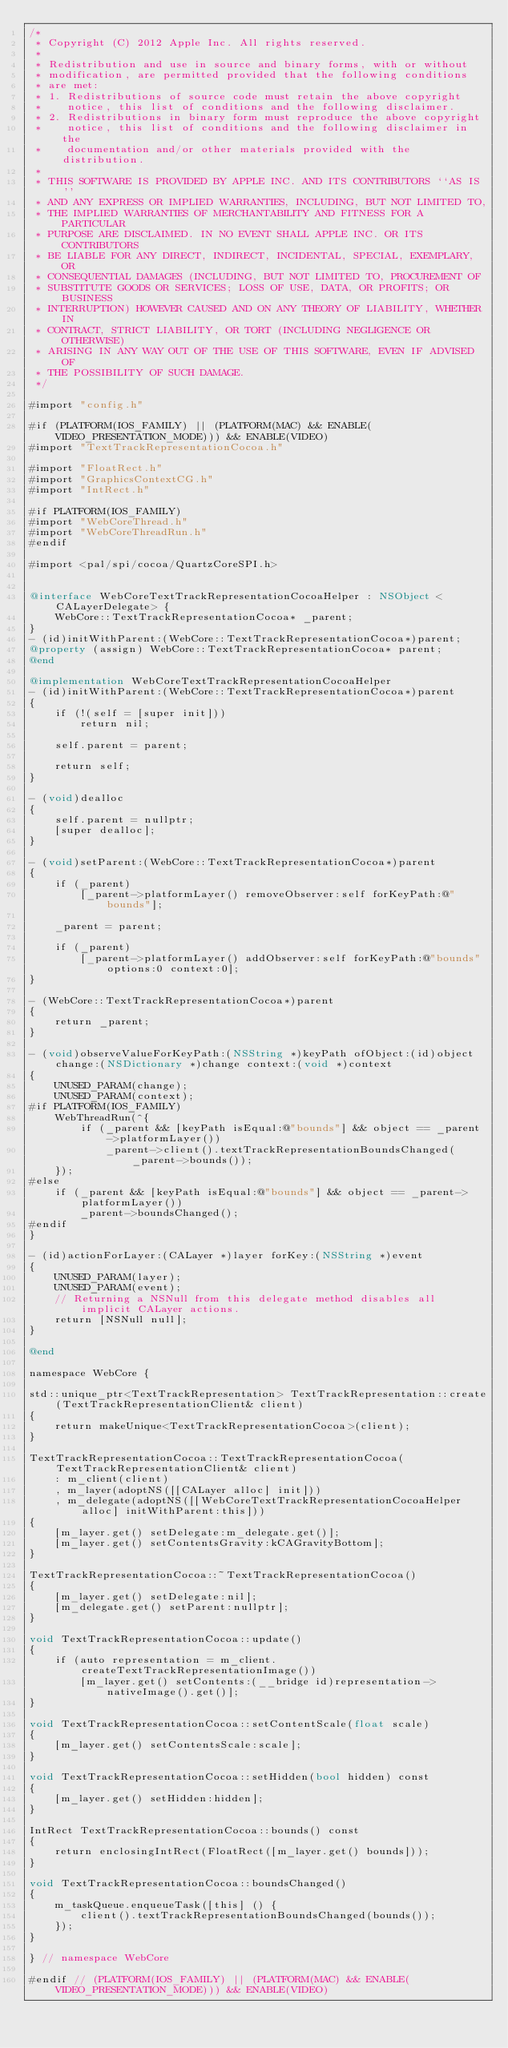Convert code to text. <code><loc_0><loc_0><loc_500><loc_500><_ObjectiveC_>/*
 * Copyright (C) 2012 Apple Inc. All rights reserved.
 *
 * Redistribution and use in source and binary forms, with or without
 * modification, are permitted provided that the following conditions
 * are met:
 * 1. Redistributions of source code must retain the above copyright
 *    notice, this list of conditions and the following disclaimer.
 * 2. Redistributions in binary form must reproduce the above copyright
 *    notice, this list of conditions and the following disclaimer in the
 *    documentation and/or other materials provided with the distribution.
 *
 * THIS SOFTWARE IS PROVIDED BY APPLE INC. AND ITS CONTRIBUTORS ``AS IS''
 * AND ANY EXPRESS OR IMPLIED WARRANTIES, INCLUDING, BUT NOT LIMITED TO,
 * THE IMPLIED WARRANTIES OF MERCHANTABILITY AND FITNESS FOR A PARTICULAR
 * PURPOSE ARE DISCLAIMED. IN NO EVENT SHALL APPLE INC. OR ITS CONTRIBUTORS
 * BE LIABLE FOR ANY DIRECT, INDIRECT, INCIDENTAL, SPECIAL, EXEMPLARY, OR
 * CONSEQUENTIAL DAMAGES (INCLUDING, BUT NOT LIMITED TO, PROCUREMENT OF
 * SUBSTITUTE GOODS OR SERVICES; LOSS OF USE, DATA, OR PROFITS; OR BUSINESS
 * INTERRUPTION) HOWEVER CAUSED AND ON ANY THEORY OF LIABILITY, WHETHER IN
 * CONTRACT, STRICT LIABILITY, OR TORT (INCLUDING NEGLIGENCE OR OTHERWISE)
 * ARISING IN ANY WAY OUT OF THE USE OF THIS SOFTWARE, EVEN IF ADVISED OF
 * THE POSSIBILITY OF SUCH DAMAGE.
 */

#import "config.h"

#if (PLATFORM(IOS_FAMILY) || (PLATFORM(MAC) && ENABLE(VIDEO_PRESENTATION_MODE))) && ENABLE(VIDEO)
#import "TextTrackRepresentationCocoa.h"

#import "FloatRect.h"
#import "GraphicsContextCG.h"
#import "IntRect.h"

#if PLATFORM(IOS_FAMILY)
#import "WebCoreThread.h"
#import "WebCoreThreadRun.h"
#endif

#import <pal/spi/cocoa/QuartzCoreSPI.h>


@interface WebCoreTextTrackRepresentationCocoaHelper : NSObject <CALayerDelegate> {
    WebCore::TextTrackRepresentationCocoa* _parent;
}
- (id)initWithParent:(WebCore::TextTrackRepresentationCocoa*)parent;
@property (assign) WebCore::TextTrackRepresentationCocoa* parent;
@end

@implementation WebCoreTextTrackRepresentationCocoaHelper
- (id)initWithParent:(WebCore::TextTrackRepresentationCocoa*)parent
{
    if (!(self = [super init]))
        return nil;

    self.parent = parent;

    return self;
}

- (void)dealloc
{
    self.parent = nullptr;
    [super dealloc];
}

- (void)setParent:(WebCore::TextTrackRepresentationCocoa*)parent
{
    if (_parent)
        [_parent->platformLayer() removeObserver:self forKeyPath:@"bounds"];

    _parent = parent;

    if (_parent)
        [_parent->platformLayer() addObserver:self forKeyPath:@"bounds" options:0 context:0];
}

- (WebCore::TextTrackRepresentationCocoa*)parent
{
    return _parent;
}

- (void)observeValueForKeyPath:(NSString *)keyPath ofObject:(id)object change:(NSDictionary *)change context:(void *)context
{
    UNUSED_PARAM(change);
    UNUSED_PARAM(context);
#if PLATFORM(IOS_FAMILY)
    WebThreadRun(^{
        if (_parent && [keyPath isEqual:@"bounds"] && object == _parent->platformLayer())
            _parent->client().textTrackRepresentationBoundsChanged(_parent->bounds());
    });
#else
    if (_parent && [keyPath isEqual:@"bounds"] && object == _parent->platformLayer())
        _parent->boundsChanged();
#endif
}

- (id)actionForLayer:(CALayer *)layer forKey:(NSString *)event
{
    UNUSED_PARAM(layer);
    UNUSED_PARAM(event);
    // Returning a NSNull from this delegate method disables all implicit CALayer actions.
    return [NSNull null];
}

@end

namespace WebCore {

std::unique_ptr<TextTrackRepresentation> TextTrackRepresentation::create(TextTrackRepresentationClient& client)
{
    return makeUnique<TextTrackRepresentationCocoa>(client);
}

TextTrackRepresentationCocoa::TextTrackRepresentationCocoa(TextTrackRepresentationClient& client)
    : m_client(client)
    , m_layer(adoptNS([[CALayer alloc] init]))
    , m_delegate(adoptNS([[WebCoreTextTrackRepresentationCocoaHelper alloc] initWithParent:this]))
{
    [m_layer.get() setDelegate:m_delegate.get()];
    [m_layer.get() setContentsGravity:kCAGravityBottom];
}

TextTrackRepresentationCocoa::~TextTrackRepresentationCocoa()
{
    [m_layer.get() setDelegate:nil];
    [m_delegate.get() setParent:nullptr];
}

void TextTrackRepresentationCocoa::update()
{
    if (auto representation = m_client.createTextTrackRepresentationImage())
        [m_layer.get() setContents:(__bridge id)representation->nativeImage().get()];
}

void TextTrackRepresentationCocoa::setContentScale(float scale)
{
    [m_layer.get() setContentsScale:scale];
}

void TextTrackRepresentationCocoa::setHidden(bool hidden) const
{
    [m_layer.get() setHidden:hidden];
}

IntRect TextTrackRepresentationCocoa::bounds() const
{
    return enclosingIntRect(FloatRect([m_layer.get() bounds]));
}

void TextTrackRepresentationCocoa::boundsChanged()
{
    m_taskQueue.enqueueTask([this] () {
        client().textTrackRepresentationBoundsChanged(bounds());
    });
}

} // namespace WebCore

#endif // (PLATFORM(IOS_FAMILY) || (PLATFORM(MAC) && ENABLE(VIDEO_PRESENTATION_MODE))) && ENABLE(VIDEO)
</code> 